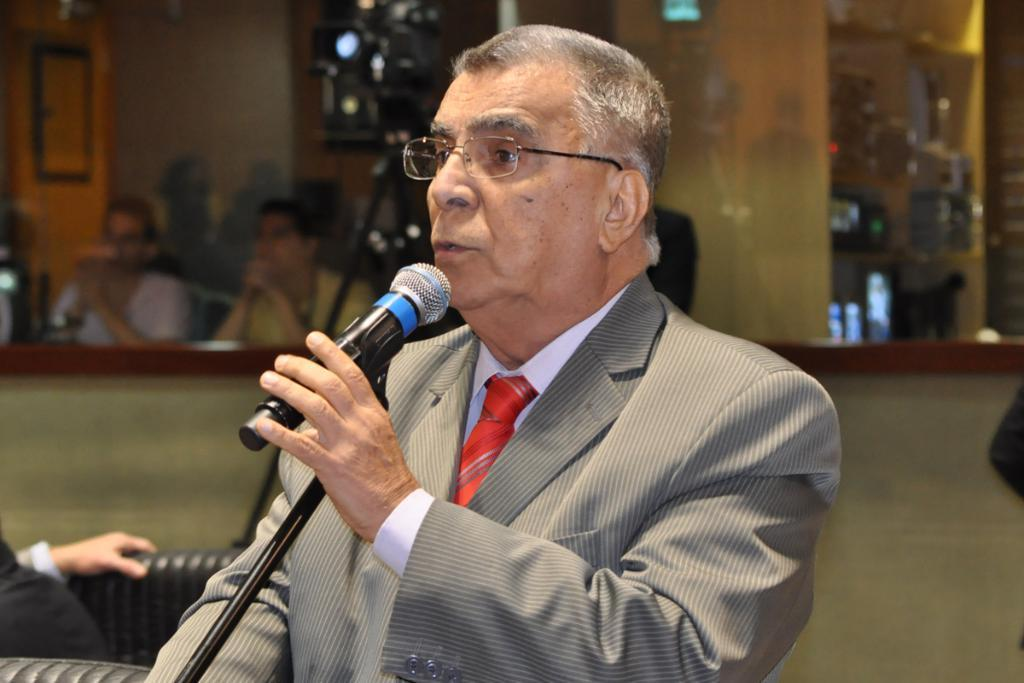Who is the main subject in the image? There is a man in the center of the image. What is the man holding in the image? The man is holding a microphone. Can you describe the background of the image? There are additional persons in the background of the image, and there is a wall visible. What type of root can be seen growing on the wall in the image? There is no root visible in the image; only a wall is present in the background. 